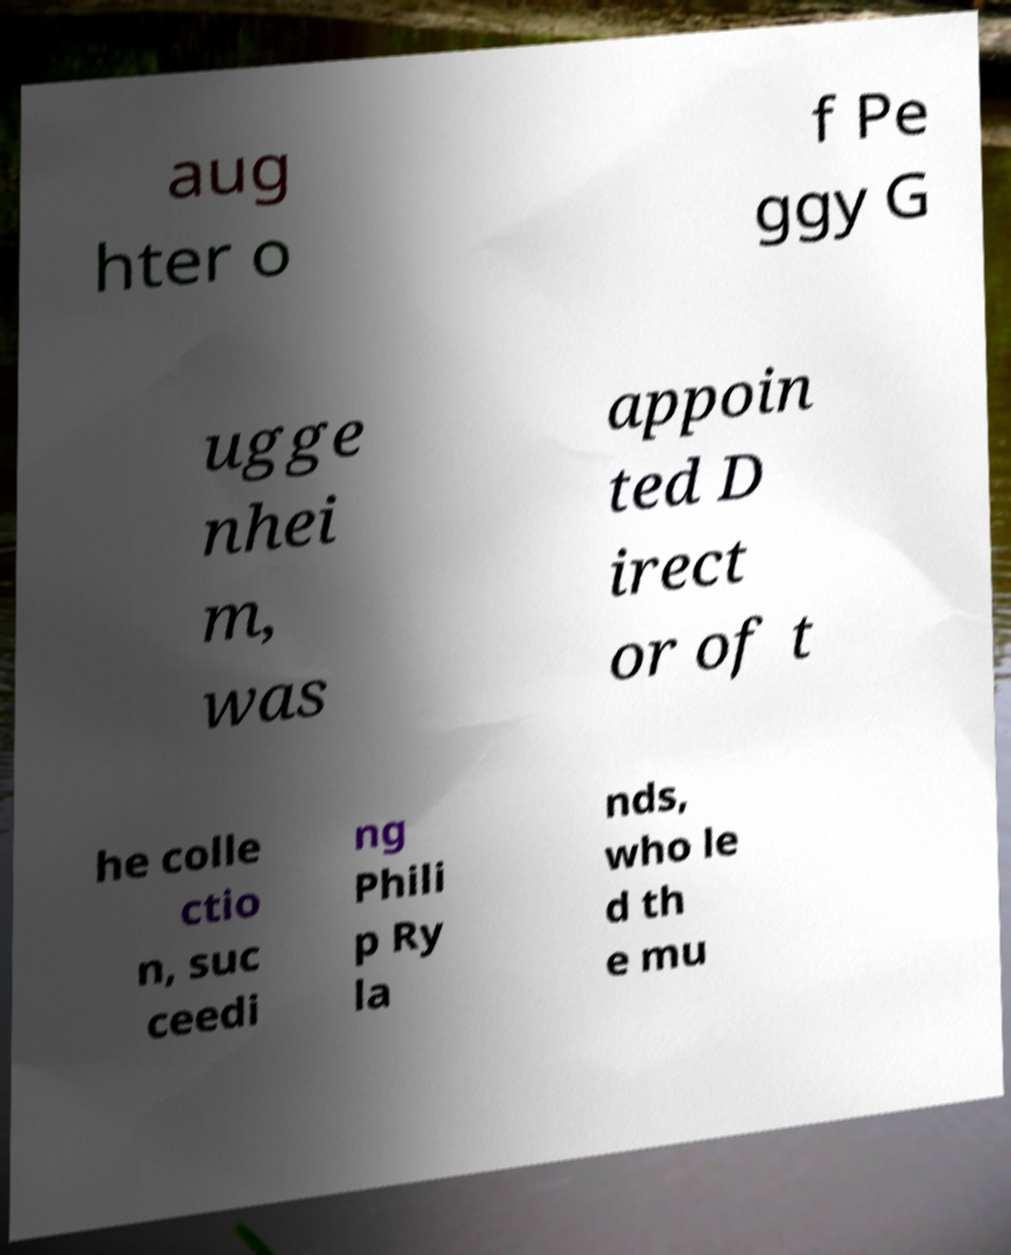For documentation purposes, I need the text within this image transcribed. Could you provide that? aug hter o f Pe ggy G ugge nhei m, was appoin ted D irect or of t he colle ctio n, suc ceedi ng Phili p Ry la nds, who le d th e mu 